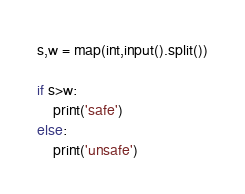<code> <loc_0><loc_0><loc_500><loc_500><_Python_>s,w = map(int,input().split())

if s>w:
    print('safe')
else:
    print('unsafe')</code> 